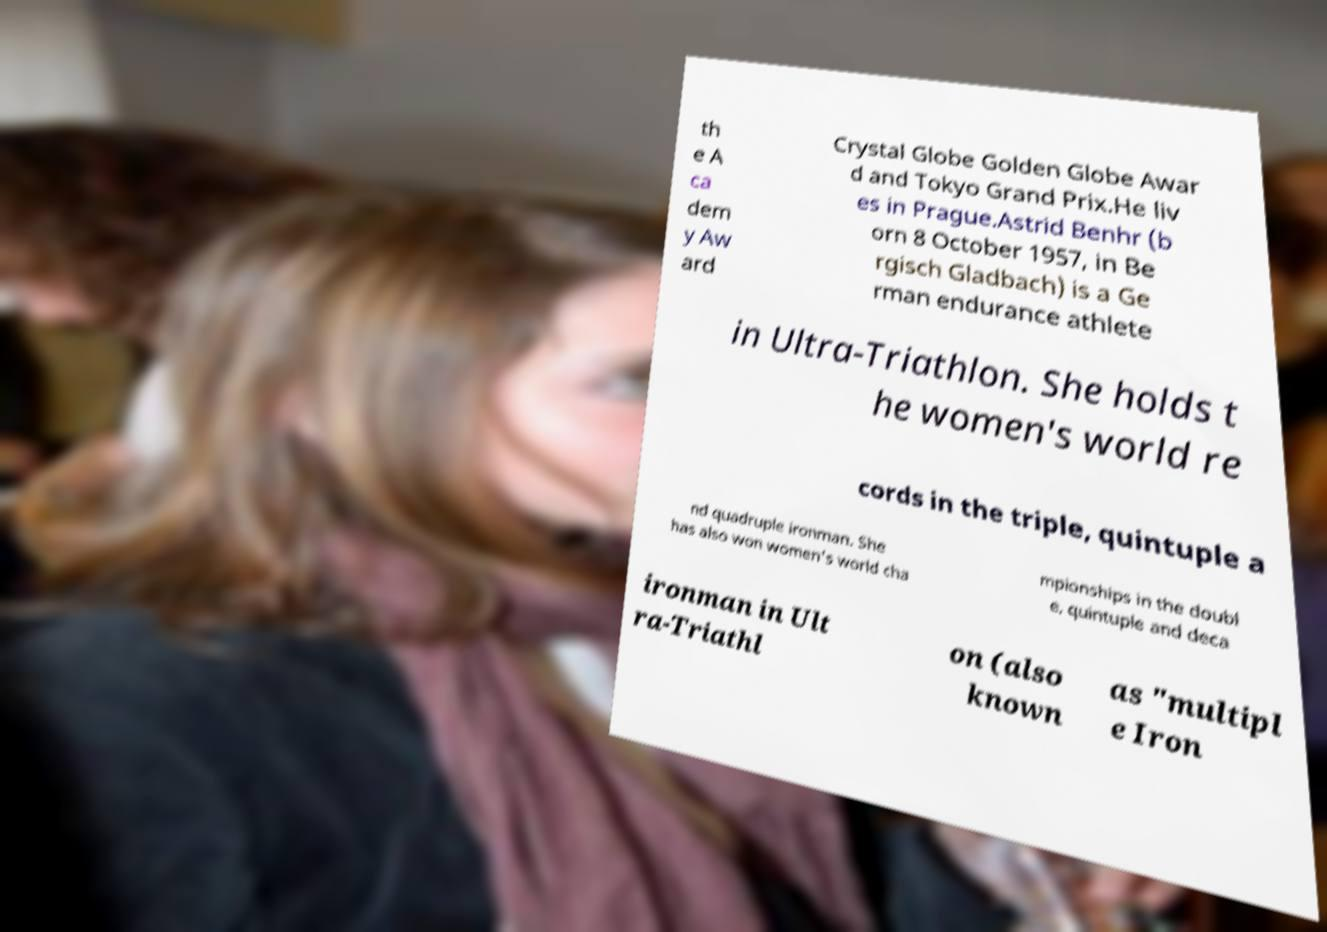Could you assist in decoding the text presented in this image and type it out clearly? th e A ca dem y Aw ard Crystal Globe Golden Globe Awar d and Tokyo Grand Prix.He liv es in Prague.Astrid Benhr (b orn 8 October 1957, in Be rgisch Gladbach) is a Ge rman endurance athlete in Ultra-Triathlon. She holds t he women's world re cords in the triple, quintuple a nd quadruple ironman. She has also won women's world cha mpionships in the doubl e, quintuple and deca ironman in Ult ra-Triathl on (also known as "multipl e Iron 